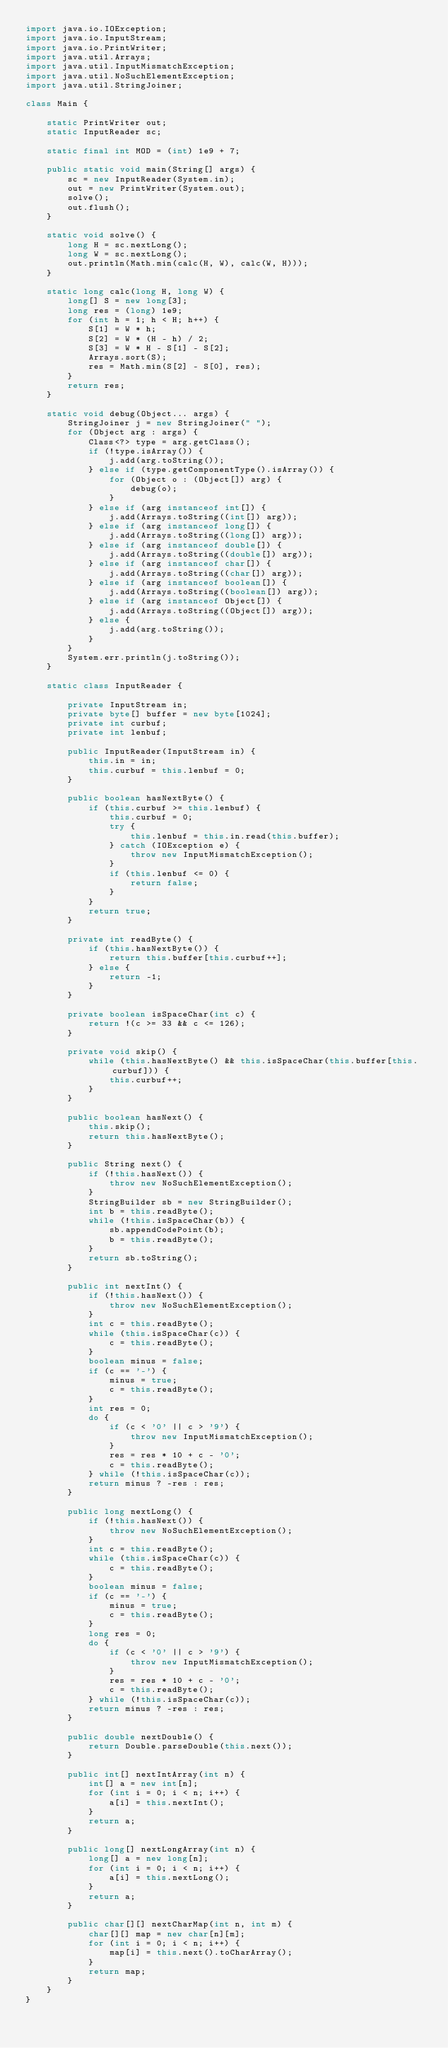Convert code to text. <code><loc_0><loc_0><loc_500><loc_500><_Java_>import java.io.IOException;
import java.io.InputStream;
import java.io.PrintWriter;
import java.util.Arrays;
import java.util.InputMismatchException;
import java.util.NoSuchElementException;
import java.util.StringJoiner;

class Main {

    static PrintWriter out;
    static InputReader sc;

    static final int MOD = (int) 1e9 + 7;

    public static void main(String[] args) {
        sc = new InputReader(System.in);
        out = new PrintWriter(System.out);
        solve();
        out.flush();
    }

    static void solve() {
        long H = sc.nextLong();
        long W = sc.nextLong();
        out.println(Math.min(calc(H, W), calc(W, H)));
    }

    static long calc(long H, long W) {
        long[] S = new long[3];
        long res = (long) 1e9;
        for (int h = 1; h < H; h++) {
            S[1] = W * h;
            S[2] = W * (H - h) / 2;
            S[3] = W * H - S[1] - S[2];
            Arrays.sort(S);
            res = Math.min(S[2] - S[0], res);
        }
        return res;
    }

    static void debug(Object... args) {
        StringJoiner j = new StringJoiner(" ");
        for (Object arg : args) {
            Class<?> type = arg.getClass();
            if (!type.isArray()) {
                j.add(arg.toString());
            } else if (type.getComponentType().isArray()) {
                for (Object o : (Object[]) arg) {
                    debug(o);
                }
            } else if (arg instanceof int[]) {
                j.add(Arrays.toString((int[]) arg));
            } else if (arg instanceof long[]) {
                j.add(Arrays.toString((long[]) arg));
            } else if (arg instanceof double[]) {
                j.add(Arrays.toString((double[]) arg));
            } else if (arg instanceof char[]) {
                j.add(Arrays.toString((char[]) arg));
            } else if (arg instanceof boolean[]) {
                j.add(Arrays.toString((boolean[]) arg));
            } else if (arg instanceof Object[]) {
                j.add(Arrays.toString((Object[]) arg));
            } else {
                j.add(arg.toString());
            }
        }
        System.err.println(j.toString());
    }

    static class InputReader {

        private InputStream in;
        private byte[] buffer = new byte[1024];
        private int curbuf;
        private int lenbuf;

        public InputReader(InputStream in) {
            this.in = in;
            this.curbuf = this.lenbuf = 0;
        }

        public boolean hasNextByte() {
            if (this.curbuf >= this.lenbuf) {
                this.curbuf = 0;
                try {
                    this.lenbuf = this.in.read(this.buffer);
                } catch (IOException e) {
                    throw new InputMismatchException();
                }
                if (this.lenbuf <= 0) {
                    return false;
                }
            }
            return true;
        }

        private int readByte() {
            if (this.hasNextByte()) {
                return this.buffer[this.curbuf++];
            } else {
                return -1;
            }
        }

        private boolean isSpaceChar(int c) {
            return !(c >= 33 && c <= 126);
        }

        private void skip() {
            while (this.hasNextByte() && this.isSpaceChar(this.buffer[this.curbuf])) {
                this.curbuf++;
            }
        }

        public boolean hasNext() {
            this.skip();
            return this.hasNextByte();
        }

        public String next() {
            if (!this.hasNext()) {
                throw new NoSuchElementException();
            }
            StringBuilder sb = new StringBuilder();
            int b = this.readByte();
            while (!this.isSpaceChar(b)) {
                sb.appendCodePoint(b);
                b = this.readByte();
            }
            return sb.toString();
        }

        public int nextInt() {
            if (!this.hasNext()) {
                throw new NoSuchElementException();
            }
            int c = this.readByte();
            while (this.isSpaceChar(c)) {
                c = this.readByte();
            }
            boolean minus = false;
            if (c == '-') {
                minus = true;
                c = this.readByte();
            }
            int res = 0;
            do {
                if (c < '0' || c > '9') {
                    throw new InputMismatchException();
                }
                res = res * 10 + c - '0';
                c = this.readByte();
            } while (!this.isSpaceChar(c));
            return minus ? -res : res;
        }

        public long nextLong() {
            if (!this.hasNext()) {
                throw new NoSuchElementException();
            }
            int c = this.readByte();
            while (this.isSpaceChar(c)) {
                c = this.readByte();
            }
            boolean minus = false;
            if (c == '-') {
                minus = true;
                c = this.readByte();
            }
            long res = 0;
            do {
                if (c < '0' || c > '9') {
                    throw new InputMismatchException();
                }
                res = res * 10 + c - '0';
                c = this.readByte();
            } while (!this.isSpaceChar(c));
            return minus ? -res : res;
        }

        public double nextDouble() {
            return Double.parseDouble(this.next());
        }

        public int[] nextIntArray(int n) {
            int[] a = new int[n];
            for (int i = 0; i < n; i++) {
                a[i] = this.nextInt();
            }
            return a;
        }

        public long[] nextLongArray(int n) {
            long[] a = new long[n];
            for (int i = 0; i < n; i++) {
                a[i] = this.nextLong();
            }
            return a;
        }

        public char[][] nextCharMap(int n, int m) {
            char[][] map = new char[n][m];
            for (int i = 0; i < n; i++) {
                map[i] = this.next().toCharArray();
            }
            return map;
        }
    }
}</code> 